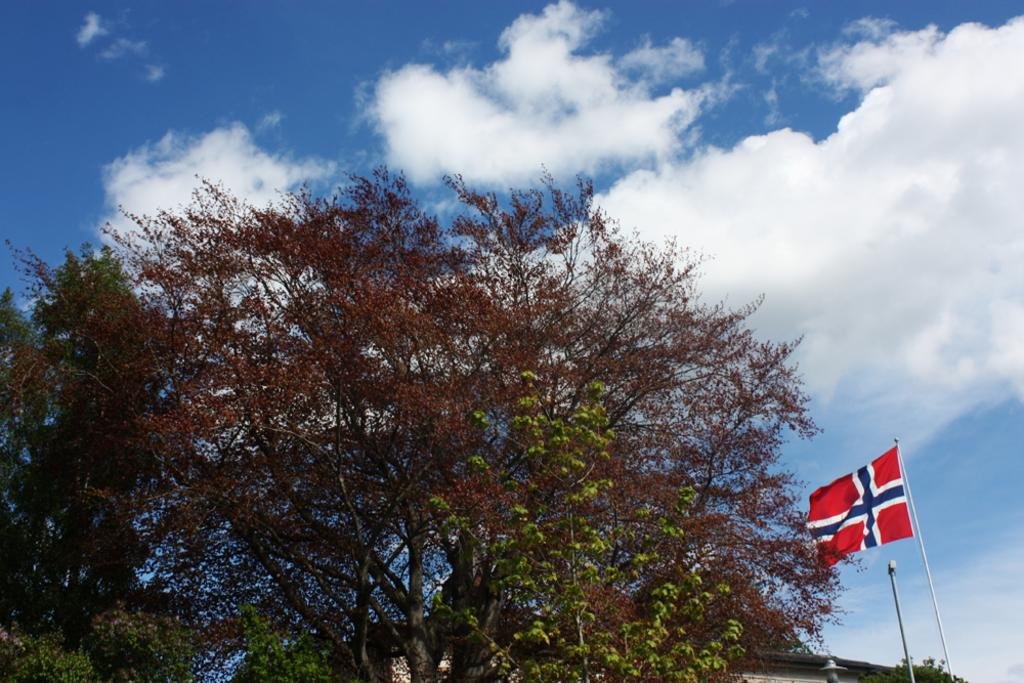What type of plant can be seen in the image? There is a tree in the image. What colors are present on the tree? The tree has green and brown colors. What is the other object visible in the image? There is a flag in the image. What can be seen in the background of the image? There is a building, a pole, and the sky visible in the background of the image. Where is the aunt standing with her spade in the image? There is no aunt or spade present in the image. What type of quiver is attached to the tree in the image? There is no quiver present in the image; it features a tree, a flag, and a background with a building, a pole, and the sky. 